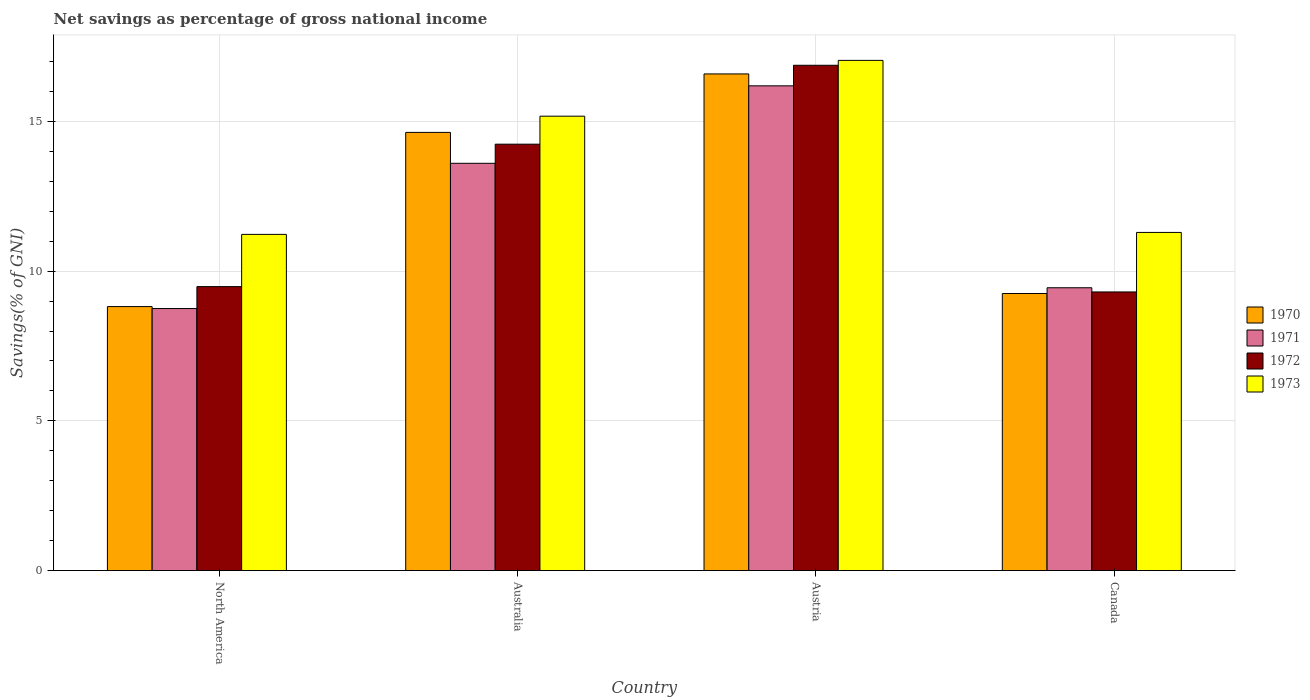How many different coloured bars are there?
Keep it short and to the point. 4. Are the number of bars per tick equal to the number of legend labels?
Provide a succinct answer. Yes. How many bars are there on the 4th tick from the right?
Your answer should be very brief. 4. What is the total savings in 1973 in North America?
Your response must be concise. 11.23. Across all countries, what is the maximum total savings in 1973?
Your answer should be compact. 17.04. Across all countries, what is the minimum total savings in 1971?
Your answer should be very brief. 8.75. What is the total total savings in 1973 in the graph?
Give a very brief answer. 54.74. What is the difference between the total savings in 1971 in Austria and that in Canada?
Your response must be concise. 6.74. What is the difference between the total savings in 1973 in North America and the total savings in 1972 in Australia?
Your answer should be compact. -3.01. What is the average total savings in 1972 per country?
Your response must be concise. 12.48. What is the difference between the total savings of/in 1972 and total savings of/in 1970 in North America?
Ensure brevity in your answer.  0.67. What is the ratio of the total savings in 1972 in Canada to that in North America?
Your response must be concise. 0.98. Is the total savings in 1973 in Austria less than that in North America?
Your answer should be compact. No. Is the difference between the total savings in 1972 in Australia and North America greater than the difference between the total savings in 1970 in Australia and North America?
Your answer should be very brief. No. What is the difference between the highest and the second highest total savings in 1972?
Ensure brevity in your answer.  7.39. What is the difference between the highest and the lowest total savings in 1971?
Your answer should be compact. 7.44. Is it the case that in every country, the sum of the total savings in 1970 and total savings in 1971 is greater than the sum of total savings in 1972 and total savings in 1973?
Offer a terse response. No. What does the 1st bar from the left in Canada represents?
Ensure brevity in your answer.  1970. What does the 1st bar from the right in North America represents?
Your answer should be compact. 1973. Is it the case that in every country, the sum of the total savings in 1970 and total savings in 1973 is greater than the total savings in 1972?
Offer a terse response. Yes. Are all the bars in the graph horizontal?
Make the answer very short. No. What is the difference between two consecutive major ticks on the Y-axis?
Offer a terse response. 5. Does the graph contain any zero values?
Give a very brief answer. No. Does the graph contain grids?
Ensure brevity in your answer.  Yes. Where does the legend appear in the graph?
Ensure brevity in your answer.  Center right. How many legend labels are there?
Ensure brevity in your answer.  4. What is the title of the graph?
Keep it short and to the point. Net savings as percentage of gross national income. Does "1997" appear as one of the legend labels in the graph?
Your answer should be very brief. No. What is the label or title of the X-axis?
Offer a terse response. Country. What is the label or title of the Y-axis?
Your response must be concise. Savings(% of GNI). What is the Savings(% of GNI) in 1970 in North America?
Provide a short and direct response. 8.82. What is the Savings(% of GNI) of 1971 in North America?
Your answer should be very brief. 8.75. What is the Savings(% of GNI) in 1972 in North America?
Offer a terse response. 9.48. What is the Savings(% of GNI) in 1973 in North America?
Give a very brief answer. 11.23. What is the Savings(% of GNI) of 1970 in Australia?
Ensure brevity in your answer.  14.63. What is the Savings(% of GNI) in 1971 in Australia?
Ensure brevity in your answer.  13.6. What is the Savings(% of GNI) of 1972 in Australia?
Provide a succinct answer. 14.24. What is the Savings(% of GNI) in 1973 in Australia?
Your answer should be very brief. 15.18. What is the Savings(% of GNI) of 1970 in Austria?
Offer a very short reply. 16.59. What is the Savings(% of GNI) of 1971 in Austria?
Your response must be concise. 16.19. What is the Savings(% of GNI) in 1972 in Austria?
Give a very brief answer. 16.88. What is the Savings(% of GNI) of 1973 in Austria?
Make the answer very short. 17.04. What is the Savings(% of GNI) of 1970 in Canada?
Offer a terse response. 9.25. What is the Savings(% of GNI) of 1971 in Canada?
Offer a terse response. 9.45. What is the Savings(% of GNI) in 1972 in Canada?
Give a very brief answer. 9.31. What is the Savings(% of GNI) in 1973 in Canada?
Provide a succinct answer. 11.29. Across all countries, what is the maximum Savings(% of GNI) of 1970?
Provide a short and direct response. 16.59. Across all countries, what is the maximum Savings(% of GNI) in 1971?
Provide a short and direct response. 16.19. Across all countries, what is the maximum Savings(% of GNI) of 1972?
Your answer should be very brief. 16.88. Across all countries, what is the maximum Savings(% of GNI) of 1973?
Provide a short and direct response. 17.04. Across all countries, what is the minimum Savings(% of GNI) in 1970?
Your response must be concise. 8.82. Across all countries, what is the minimum Savings(% of GNI) of 1971?
Make the answer very short. 8.75. Across all countries, what is the minimum Savings(% of GNI) of 1972?
Make the answer very short. 9.31. Across all countries, what is the minimum Savings(% of GNI) of 1973?
Provide a short and direct response. 11.23. What is the total Savings(% of GNI) of 1970 in the graph?
Offer a terse response. 49.29. What is the total Savings(% of GNI) of 1971 in the graph?
Make the answer very short. 47.99. What is the total Savings(% of GNI) of 1972 in the graph?
Make the answer very short. 49.91. What is the total Savings(% of GNI) in 1973 in the graph?
Your response must be concise. 54.74. What is the difference between the Savings(% of GNI) of 1970 in North America and that in Australia?
Provide a succinct answer. -5.82. What is the difference between the Savings(% of GNI) in 1971 in North America and that in Australia?
Your answer should be very brief. -4.85. What is the difference between the Savings(% of GNI) of 1972 in North America and that in Australia?
Keep it short and to the point. -4.76. What is the difference between the Savings(% of GNI) in 1973 in North America and that in Australia?
Ensure brevity in your answer.  -3.95. What is the difference between the Savings(% of GNI) in 1970 in North America and that in Austria?
Offer a very short reply. -7.77. What is the difference between the Savings(% of GNI) in 1971 in North America and that in Austria?
Provide a succinct answer. -7.44. What is the difference between the Savings(% of GNI) of 1972 in North America and that in Austria?
Your answer should be compact. -7.39. What is the difference between the Savings(% of GNI) of 1973 in North America and that in Austria?
Offer a very short reply. -5.81. What is the difference between the Savings(% of GNI) in 1970 in North America and that in Canada?
Give a very brief answer. -0.44. What is the difference between the Savings(% of GNI) in 1971 in North America and that in Canada?
Your response must be concise. -0.69. What is the difference between the Savings(% of GNI) in 1972 in North America and that in Canada?
Provide a short and direct response. 0.18. What is the difference between the Savings(% of GNI) of 1973 in North America and that in Canada?
Your answer should be very brief. -0.07. What is the difference between the Savings(% of GNI) in 1970 in Australia and that in Austria?
Your answer should be very brief. -1.95. What is the difference between the Savings(% of GNI) in 1971 in Australia and that in Austria?
Provide a short and direct response. -2.59. What is the difference between the Savings(% of GNI) in 1972 in Australia and that in Austria?
Provide a short and direct response. -2.64. What is the difference between the Savings(% of GNI) in 1973 in Australia and that in Austria?
Keep it short and to the point. -1.86. What is the difference between the Savings(% of GNI) in 1970 in Australia and that in Canada?
Ensure brevity in your answer.  5.38. What is the difference between the Savings(% of GNI) in 1971 in Australia and that in Canada?
Provide a succinct answer. 4.16. What is the difference between the Savings(% of GNI) in 1972 in Australia and that in Canada?
Keep it short and to the point. 4.93. What is the difference between the Savings(% of GNI) of 1973 in Australia and that in Canada?
Your response must be concise. 3.88. What is the difference between the Savings(% of GNI) in 1970 in Austria and that in Canada?
Provide a short and direct response. 7.33. What is the difference between the Savings(% of GNI) in 1971 in Austria and that in Canada?
Make the answer very short. 6.74. What is the difference between the Savings(% of GNI) of 1972 in Austria and that in Canada?
Your response must be concise. 7.57. What is the difference between the Savings(% of GNI) of 1973 in Austria and that in Canada?
Provide a succinct answer. 5.75. What is the difference between the Savings(% of GNI) in 1970 in North America and the Savings(% of GNI) in 1971 in Australia?
Provide a short and direct response. -4.78. What is the difference between the Savings(% of GNI) in 1970 in North America and the Savings(% of GNI) in 1972 in Australia?
Keep it short and to the point. -5.42. What is the difference between the Savings(% of GNI) of 1970 in North America and the Savings(% of GNI) of 1973 in Australia?
Your answer should be very brief. -6.36. What is the difference between the Savings(% of GNI) of 1971 in North America and the Savings(% of GNI) of 1972 in Australia?
Make the answer very short. -5.49. What is the difference between the Savings(% of GNI) in 1971 in North America and the Savings(% of GNI) in 1973 in Australia?
Offer a very short reply. -6.42. What is the difference between the Savings(% of GNI) in 1972 in North America and the Savings(% of GNI) in 1973 in Australia?
Provide a short and direct response. -5.69. What is the difference between the Savings(% of GNI) of 1970 in North America and the Savings(% of GNI) of 1971 in Austria?
Give a very brief answer. -7.37. What is the difference between the Savings(% of GNI) in 1970 in North America and the Savings(% of GNI) in 1972 in Austria?
Offer a terse response. -8.06. What is the difference between the Savings(% of GNI) of 1970 in North America and the Savings(% of GNI) of 1973 in Austria?
Ensure brevity in your answer.  -8.22. What is the difference between the Savings(% of GNI) in 1971 in North America and the Savings(% of GNI) in 1972 in Austria?
Your response must be concise. -8.12. What is the difference between the Savings(% of GNI) of 1971 in North America and the Savings(% of GNI) of 1973 in Austria?
Offer a very short reply. -8.29. What is the difference between the Savings(% of GNI) of 1972 in North America and the Savings(% of GNI) of 1973 in Austria?
Make the answer very short. -7.56. What is the difference between the Savings(% of GNI) of 1970 in North America and the Savings(% of GNI) of 1971 in Canada?
Provide a short and direct response. -0.63. What is the difference between the Savings(% of GNI) in 1970 in North America and the Savings(% of GNI) in 1972 in Canada?
Keep it short and to the point. -0.49. What is the difference between the Savings(% of GNI) in 1970 in North America and the Savings(% of GNI) in 1973 in Canada?
Ensure brevity in your answer.  -2.48. What is the difference between the Savings(% of GNI) in 1971 in North America and the Savings(% of GNI) in 1972 in Canada?
Offer a terse response. -0.55. What is the difference between the Savings(% of GNI) in 1971 in North America and the Savings(% of GNI) in 1973 in Canada?
Provide a short and direct response. -2.54. What is the difference between the Savings(% of GNI) in 1972 in North America and the Savings(% of GNI) in 1973 in Canada?
Your answer should be very brief. -1.81. What is the difference between the Savings(% of GNI) in 1970 in Australia and the Savings(% of GNI) in 1971 in Austria?
Your answer should be very brief. -1.55. What is the difference between the Savings(% of GNI) in 1970 in Australia and the Savings(% of GNI) in 1972 in Austria?
Keep it short and to the point. -2.24. What is the difference between the Savings(% of GNI) in 1970 in Australia and the Savings(% of GNI) in 1973 in Austria?
Your answer should be compact. -2.4. What is the difference between the Savings(% of GNI) in 1971 in Australia and the Savings(% of GNI) in 1972 in Austria?
Your response must be concise. -3.27. What is the difference between the Savings(% of GNI) in 1971 in Australia and the Savings(% of GNI) in 1973 in Austria?
Keep it short and to the point. -3.44. What is the difference between the Savings(% of GNI) in 1972 in Australia and the Savings(% of GNI) in 1973 in Austria?
Keep it short and to the point. -2.8. What is the difference between the Savings(% of GNI) of 1970 in Australia and the Savings(% of GNI) of 1971 in Canada?
Your answer should be very brief. 5.19. What is the difference between the Savings(% of GNI) of 1970 in Australia and the Savings(% of GNI) of 1972 in Canada?
Offer a terse response. 5.33. What is the difference between the Savings(% of GNI) of 1970 in Australia and the Savings(% of GNI) of 1973 in Canada?
Give a very brief answer. 3.34. What is the difference between the Savings(% of GNI) of 1971 in Australia and the Savings(% of GNI) of 1972 in Canada?
Offer a very short reply. 4.3. What is the difference between the Savings(% of GNI) in 1971 in Australia and the Savings(% of GNI) in 1973 in Canada?
Offer a terse response. 2.31. What is the difference between the Savings(% of GNI) in 1972 in Australia and the Savings(% of GNI) in 1973 in Canada?
Make the answer very short. 2.95. What is the difference between the Savings(% of GNI) in 1970 in Austria and the Savings(% of GNI) in 1971 in Canada?
Keep it short and to the point. 7.14. What is the difference between the Savings(% of GNI) of 1970 in Austria and the Savings(% of GNI) of 1972 in Canada?
Keep it short and to the point. 7.28. What is the difference between the Savings(% of GNI) in 1970 in Austria and the Savings(% of GNI) in 1973 in Canada?
Provide a short and direct response. 5.29. What is the difference between the Savings(% of GNI) in 1971 in Austria and the Savings(% of GNI) in 1972 in Canada?
Your answer should be very brief. 6.88. What is the difference between the Savings(% of GNI) in 1971 in Austria and the Savings(% of GNI) in 1973 in Canada?
Give a very brief answer. 4.9. What is the difference between the Savings(% of GNI) in 1972 in Austria and the Savings(% of GNI) in 1973 in Canada?
Your answer should be very brief. 5.58. What is the average Savings(% of GNI) of 1970 per country?
Offer a terse response. 12.32. What is the average Savings(% of GNI) of 1971 per country?
Make the answer very short. 12. What is the average Savings(% of GNI) of 1972 per country?
Your answer should be compact. 12.48. What is the average Savings(% of GNI) of 1973 per country?
Your answer should be very brief. 13.68. What is the difference between the Savings(% of GNI) of 1970 and Savings(% of GNI) of 1971 in North America?
Provide a short and direct response. 0.07. What is the difference between the Savings(% of GNI) in 1970 and Savings(% of GNI) in 1972 in North America?
Give a very brief answer. -0.67. What is the difference between the Savings(% of GNI) in 1970 and Savings(% of GNI) in 1973 in North America?
Offer a very short reply. -2.41. What is the difference between the Savings(% of GNI) of 1971 and Savings(% of GNI) of 1972 in North America?
Offer a very short reply. -0.73. What is the difference between the Savings(% of GNI) of 1971 and Savings(% of GNI) of 1973 in North America?
Provide a short and direct response. -2.48. What is the difference between the Savings(% of GNI) in 1972 and Savings(% of GNI) in 1973 in North America?
Make the answer very short. -1.74. What is the difference between the Savings(% of GNI) of 1970 and Savings(% of GNI) of 1971 in Australia?
Your answer should be compact. 1.03. What is the difference between the Savings(% of GNI) of 1970 and Savings(% of GNI) of 1972 in Australia?
Provide a succinct answer. 0.39. What is the difference between the Savings(% of GNI) of 1970 and Savings(% of GNI) of 1973 in Australia?
Your response must be concise. -0.54. What is the difference between the Savings(% of GNI) of 1971 and Savings(% of GNI) of 1972 in Australia?
Keep it short and to the point. -0.64. What is the difference between the Savings(% of GNI) of 1971 and Savings(% of GNI) of 1973 in Australia?
Offer a very short reply. -1.57. What is the difference between the Savings(% of GNI) in 1972 and Savings(% of GNI) in 1973 in Australia?
Keep it short and to the point. -0.93. What is the difference between the Savings(% of GNI) in 1970 and Savings(% of GNI) in 1971 in Austria?
Your answer should be very brief. 0.4. What is the difference between the Savings(% of GNI) of 1970 and Savings(% of GNI) of 1972 in Austria?
Offer a terse response. -0.29. What is the difference between the Savings(% of GNI) of 1970 and Savings(% of GNI) of 1973 in Austria?
Your response must be concise. -0.45. What is the difference between the Savings(% of GNI) of 1971 and Savings(% of GNI) of 1972 in Austria?
Provide a succinct answer. -0.69. What is the difference between the Savings(% of GNI) of 1971 and Savings(% of GNI) of 1973 in Austria?
Provide a succinct answer. -0.85. What is the difference between the Savings(% of GNI) of 1972 and Savings(% of GNI) of 1973 in Austria?
Your answer should be compact. -0.16. What is the difference between the Savings(% of GNI) in 1970 and Savings(% of GNI) in 1971 in Canada?
Offer a very short reply. -0.19. What is the difference between the Savings(% of GNI) in 1970 and Savings(% of GNI) in 1972 in Canada?
Keep it short and to the point. -0.05. What is the difference between the Savings(% of GNI) in 1970 and Savings(% of GNI) in 1973 in Canada?
Your response must be concise. -2.04. What is the difference between the Savings(% of GNI) of 1971 and Savings(% of GNI) of 1972 in Canada?
Provide a succinct answer. 0.14. What is the difference between the Savings(% of GNI) in 1971 and Savings(% of GNI) in 1973 in Canada?
Offer a terse response. -1.85. What is the difference between the Savings(% of GNI) of 1972 and Savings(% of GNI) of 1973 in Canada?
Offer a very short reply. -1.99. What is the ratio of the Savings(% of GNI) of 1970 in North America to that in Australia?
Offer a very short reply. 0.6. What is the ratio of the Savings(% of GNI) in 1971 in North America to that in Australia?
Offer a very short reply. 0.64. What is the ratio of the Savings(% of GNI) in 1972 in North America to that in Australia?
Offer a very short reply. 0.67. What is the ratio of the Savings(% of GNI) in 1973 in North America to that in Australia?
Give a very brief answer. 0.74. What is the ratio of the Savings(% of GNI) in 1970 in North America to that in Austria?
Your answer should be very brief. 0.53. What is the ratio of the Savings(% of GNI) of 1971 in North America to that in Austria?
Provide a succinct answer. 0.54. What is the ratio of the Savings(% of GNI) in 1972 in North America to that in Austria?
Keep it short and to the point. 0.56. What is the ratio of the Savings(% of GNI) of 1973 in North America to that in Austria?
Ensure brevity in your answer.  0.66. What is the ratio of the Savings(% of GNI) of 1970 in North America to that in Canada?
Provide a short and direct response. 0.95. What is the ratio of the Savings(% of GNI) of 1971 in North America to that in Canada?
Offer a terse response. 0.93. What is the ratio of the Savings(% of GNI) in 1972 in North America to that in Canada?
Offer a terse response. 1.02. What is the ratio of the Savings(% of GNI) of 1973 in North America to that in Canada?
Provide a short and direct response. 0.99. What is the ratio of the Savings(% of GNI) of 1970 in Australia to that in Austria?
Ensure brevity in your answer.  0.88. What is the ratio of the Savings(% of GNI) of 1971 in Australia to that in Austria?
Offer a terse response. 0.84. What is the ratio of the Savings(% of GNI) in 1972 in Australia to that in Austria?
Offer a very short reply. 0.84. What is the ratio of the Savings(% of GNI) in 1973 in Australia to that in Austria?
Your response must be concise. 0.89. What is the ratio of the Savings(% of GNI) of 1970 in Australia to that in Canada?
Ensure brevity in your answer.  1.58. What is the ratio of the Savings(% of GNI) of 1971 in Australia to that in Canada?
Your answer should be very brief. 1.44. What is the ratio of the Savings(% of GNI) of 1972 in Australia to that in Canada?
Give a very brief answer. 1.53. What is the ratio of the Savings(% of GNI) of 1973 in Australia to that in Canada?
Ensure brevity in your answer.  1.34. What is the ratio of the Savings(% of GNI) of 1970 in Austria to that in Canada?
Your response must be concise. 1.79. What is the ratio of the Savings(% of GNI) of 1971 in Austria to that in Canada?
Keep it short and to the point. 1.71. What is the ratio of the Savings(% of GNI) of 1972 in Austria to that in Canada?
Make the answer very short. 1.81. What is the ratio of the Savings(% of GNI) of 1973 in Austria to that in Canada?
Provide a succinct answer. 1.51. What is the difference between the highest and the second highest Savings(% of GNI) in 1970?
Make the answer very short. 1.95. What is the difference between the highest and the second highest Savings(% of GNI) in 1971?
Your answer should be compact. 2.59. What is the difference between the highest and the second highest Savings(% of GNI) in 1972?
Provide a succinct answer. 2.64. What is the difference between the highest and the second highest Savings(% of GNI) of 1973?
Ensure brevity in your answer.  1.86. What is the difference between the highest and the lowest Savings(% of GNI) of 1970?
Ensure brevity in your answer.  7.77. What is the difference between the highest and the lowest Savings(% of GNI) of 1971?
Keep it short and to the point. 7.44. What is the difference between the highest and the lowest Savings(% of GNI) in 1972?
Give a very brief answer. 7.57. What is the difference between the highest and the lowest Savings(% of GNI) of 1973?
Your response must be concise. 5.81. 